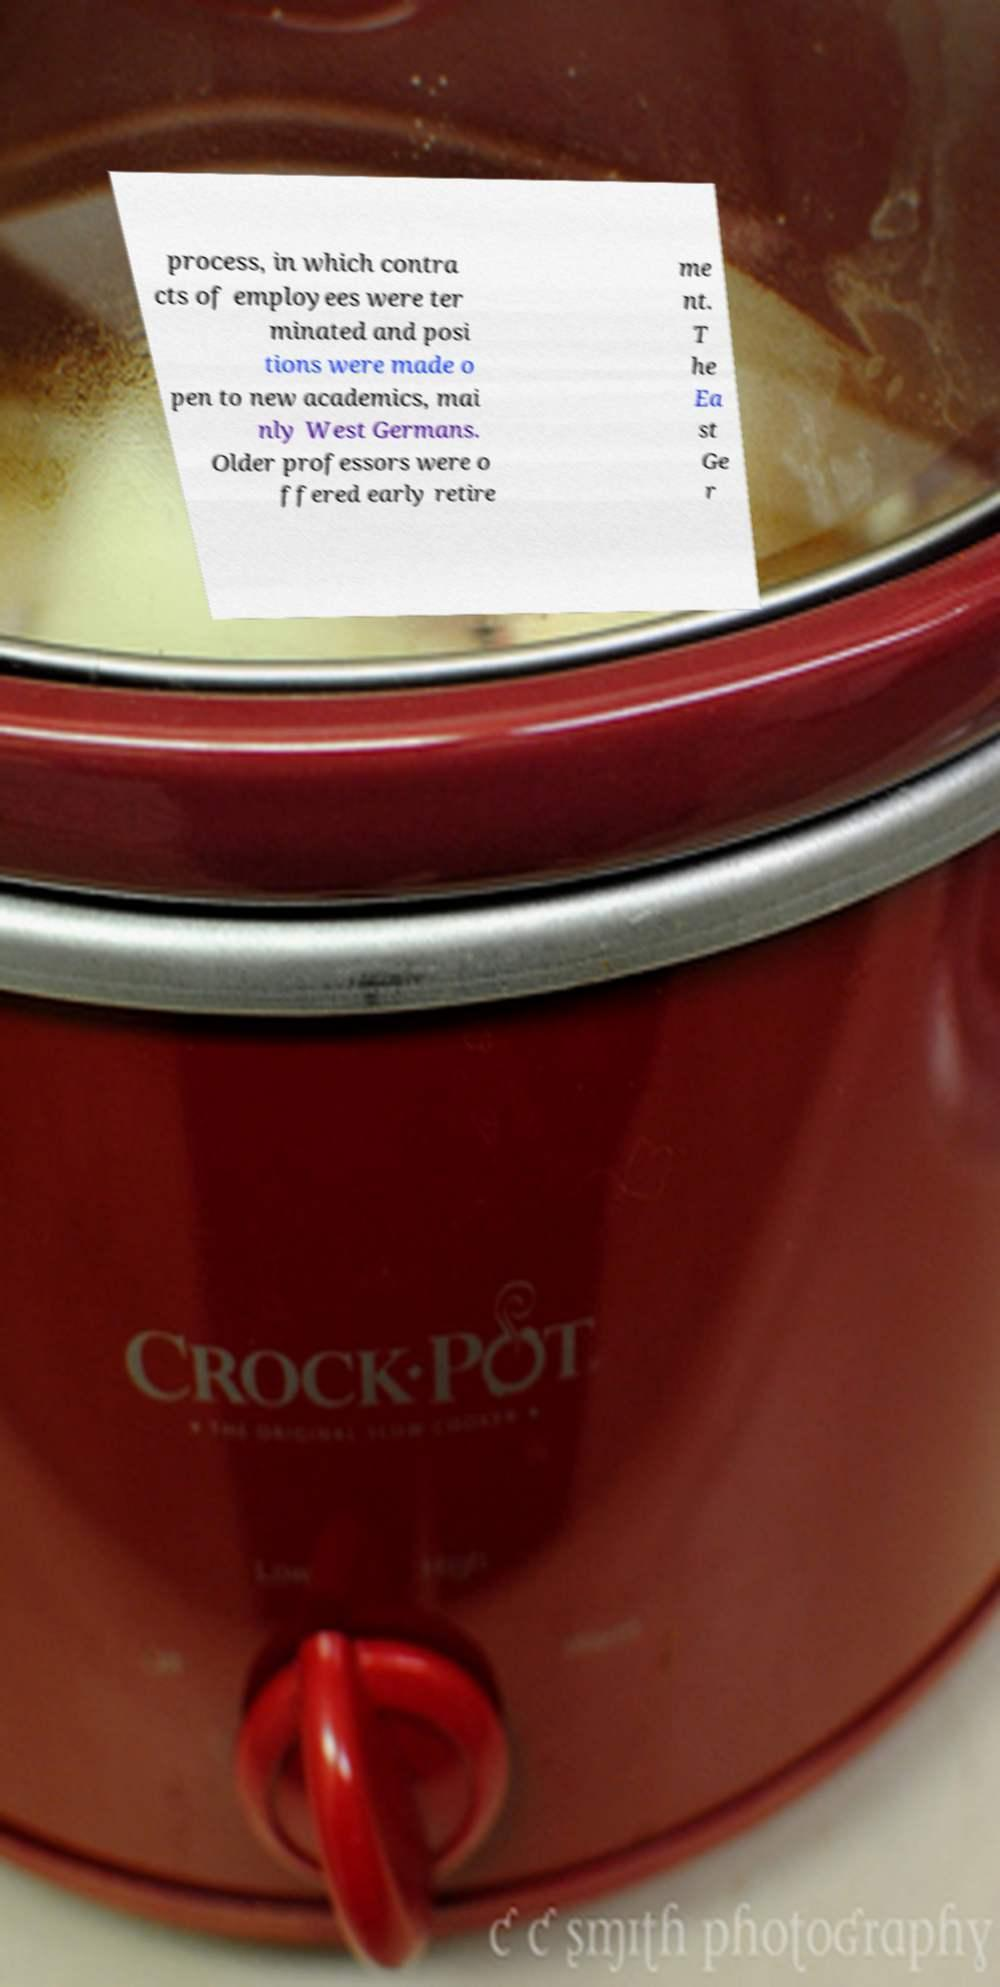Can you accurately transcribe the text from the provided image for me? process, in which contra cts of employees were ter minated and posi tions were made o pen to new academics, mai nly West Germans. Older professors were o ffered early retire me nt. T he Ea st Ge r 